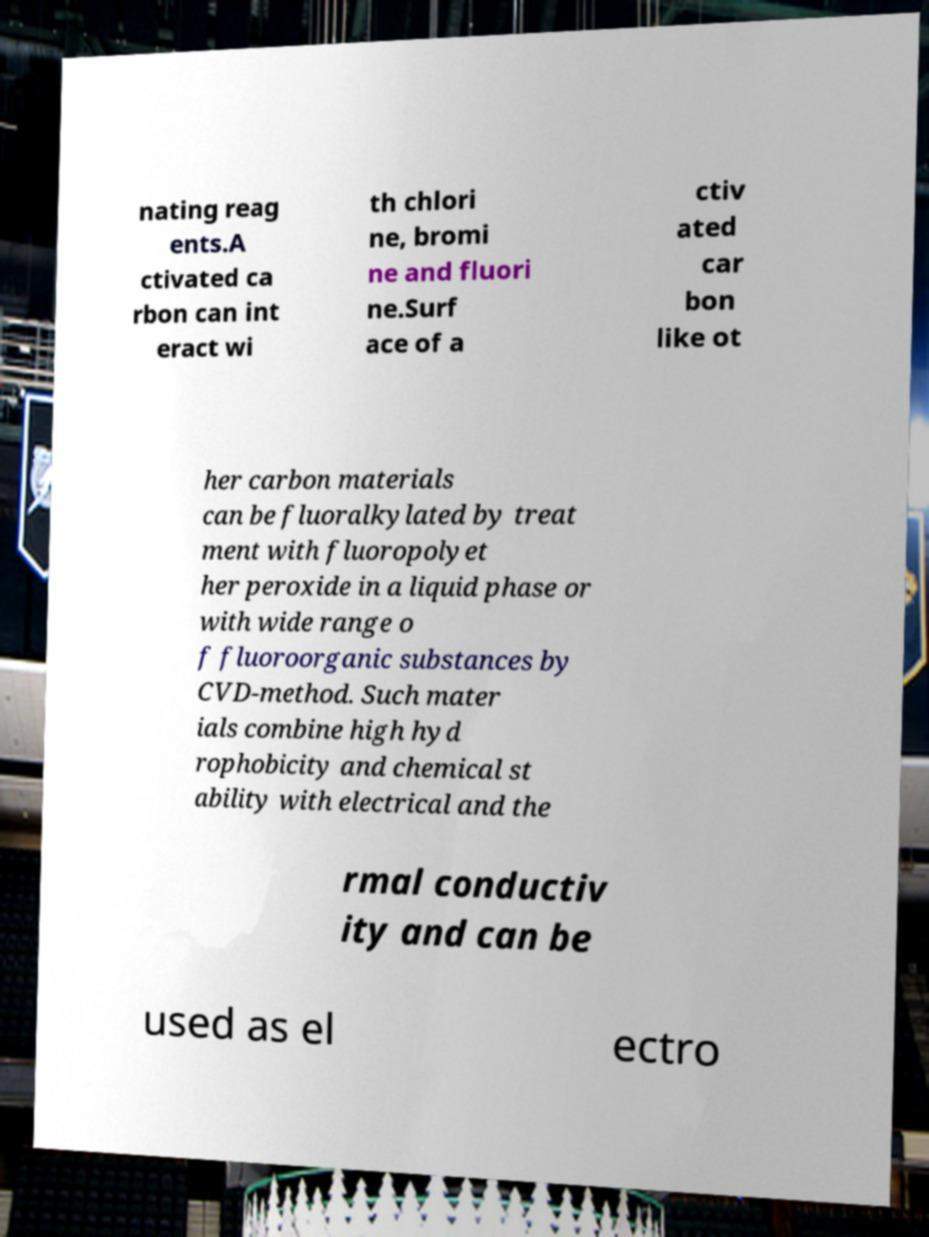Can you accurately transcribe the text from the provided image for me? nating reag ents.A ctivated ca rbon can int eract wi th chlori ne, bromi ne and fluori ne.Surf ace of a ctiv ated car bon like ot her carbon materials can be fluoralkylated by treat ment with fluoropolyet her peroxide in a liquid phase or with wide range o f fluoroorganic substances by CVD-method. Such mater ials combine high hyd rophobicity and chemical st ability with electrical and the rmal conductiv ity and can be used as el ectro 